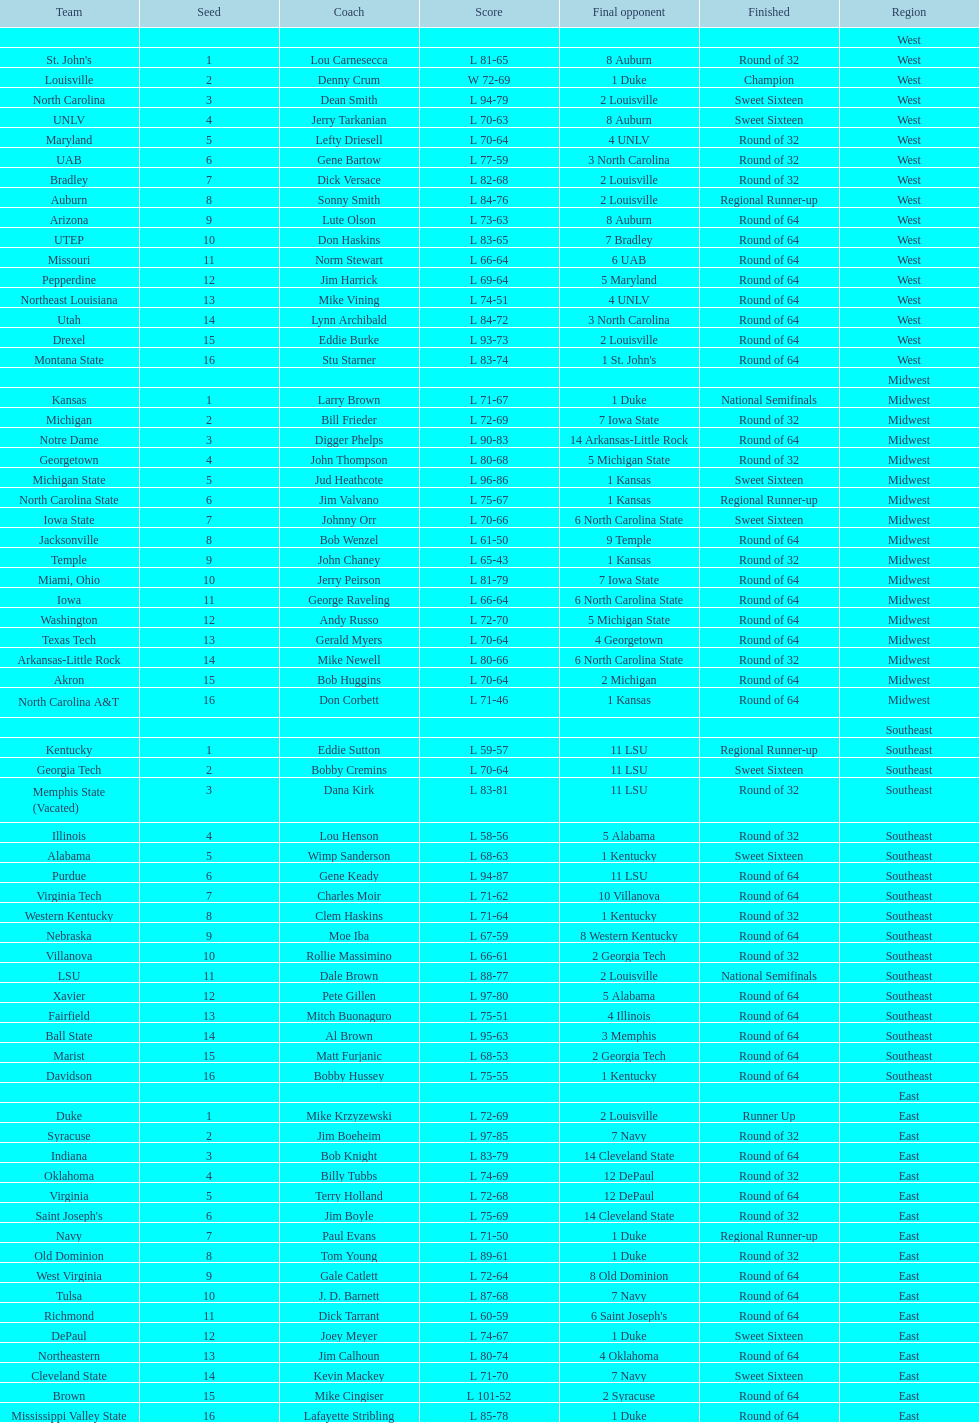What team finished at the top of all else and was finished as champions? Louisville. I'm looking to parse the entire table for insights. Could you assist me with that? {'header': ['Team', 'Seed', 'Coach', 'Score', 'Final opponent', 'Finished', 'Region'], 'rows': [['', '', '', '', '', '', 'West'], ["St. John's", '1', 'Lou Carnesecca', 'L 81-65', '8 Auburn', 'Round of 32', 'West'], ['Louisville', '2', 'Denny Crum', 'W 72-69', '1 Duke', 'Champion', 'West'], ['North Carolina', '3', 'Dean Smith', 'L 94-79', '2 Louisville', 'Sweet Sixteen', 'West'], ['UNLV', '4', 'Jerry Tarkanian', 'L 70-63', '8 Auburn', 'Sweet Sixteen', 'West'], ['Maryland', '5', 'Lefty Driesell', 'L 70-64', '4 UNLV', 'Round of 32', 'West'], ['UAB', '6', 'Gene Bartow', 'L 77-59', '3 North Carolina', 'Round of 32', 'West'], ['Bradley', '7', 'Dick Versace', 'L 82-68', '2 Louisville', 'Round of 32', 'West'], ['Auburn', '8', 'Sonny Smith', 'L 84-76', '2 Louisville', 'Regional Runner-up', 'West'], ['Arizona', '9', 'Lute Olson', 'L 73-63', '8 Auburn', 'Round of 64', 'West'], ['UTEP', '10', 'Don Haskins', 'L 83-65', '7 Bradley', 'Round of 64', 'West'], ['Missouri', '11', 'Norm Stewart', 'L 66-64', '6 UAB', 'Round of 64', 'West'], ['Pepperdine', '12', 'Jim Harrick', 'L 69-64', '5 Maryland', 'Round of 64', 'West'], ['Northeast Louisiana', '13', 'Mike Vining', 'L 74-51', '4 UNLV', 'Round of 64', 'West'], ['Utah', '14', 'Lynn Archibald', 'L 84-72', '3 North Carolina', 'Round of 64', 'West'], ['Drexel', '15', 'Eddie Burke', 'L 93-73', '2 Louisville', 'Round of 64', 'West'], ['Montana State', '16', 'Stu Starner', 'L 83-74', "1 St. John's", 'Round of 64', 'West'], ['', '', '', '', '', '', 'Midwest'], ['Kansas', '1', 'Larry Brown', 'L 71-67', '1 Duke', 'National Semifinals', 'Midwest'], ['Michigan', '2', 'Bill Frieder', 'L 72-69', '7 Iowa State', 'Round of 32', 'Midwest'], ['Notre Dame', '3', 'Digger Phelps', 'L 90-83', '14 Arkansas-Little Rock', 'Round of 64', 'Midwest'], ['Georgetown', '4', 'John Thompson', 'L 80-68', '5 Michigan State', 'Round of 32', 'Midwest'], ['Michigan State', '5', 'Jud Heathcote', 'L 96-86', '1 Kansas', 'Sweet Sixteen', 'Midwest'], ['North Carolina State', '6', 'Jim Valvano', 'L 75-67', '1 Kansas', 'Regional Runner-up', 'Midwest'], ['Iowa State', '7', 'Johnny Orr', 'L 70-66', '6 North Carolina State', 'Sweet Sixteen', 'Midwest'], ['Jacksonville', '8', 'Bob Wenzel', 'L 61-50', '9 Temple', 'Round of 64', 'Midwest'], ['Temple', '9', 'John Chaney', 'L 65-43', '1 Kansas', 'Round of 32', 'Midwest'], ['Miami, Ohio', '10', 'Jerry Peirson', 'L 81-79', '7 Iowa State', 'Round of 64', 'Midwest'], ['Iowa', '11', 'George Raveling', 'L 66-64', '6 North Carolina State', 'Round of 64', 'Midwest'], ['Washington', '12', 'Andy Russo', 'L 72-70', '5 Michigan State', 'Round of 64', 'Midwest'], ['Texas Tech', '13', 'Gerald Myers', 'L 70-64', '4 Georgetown', 'Round of 64', 'Midwest'], ['Arkansas-Little Rock', '14', 'Mike Newell', 'L 80-66', '6 North Carolina State', 'Round of 32', 'Midwest'], ['Akron', '15', 'Bob Huggins', 'L 70-64', '2 Michigan', 'Round of 64', 'Midwest'], ['North Carolina A&T', '16', 'Don Corbett', 'L 71-46', '1 Kansas', 'Round of 64', 'Midwest'], ['', '', '', '', '', '', 'Southeast'], ['Kentucky', '1', 'Eddie Sutton', 'L 59-57', '11 LSU', 'Regional Runner-up', 'Southeast'], ['Georgia Tech', '2', 'Bobby Cremins', 'L 70-64', '11 LSU', 'Sweet Sixteen', 'Southeast'], ['Memphis State (Vacated)', '3', 'Dana Kirk', 'L 83-81', '11 LSU', 'Round of 32', 'Southeast'], ['Illinois', '4', 'Lou Henson', 'L 58-56', '5 Alabama', 'Round of 32', 'Southeast'], ['Alabama', '5', 'Wimp Sanderson', 'L 68-63', '1 Kentucky', 'Sweet Sixteen', 'Southeast'], ['Purdue', '6', 'Gene Keady', 'L 94-87', '11 LSU', 'Round of 64', 'Southeast'], ['Virginia Tech', '7', 'Charles Moir', 'L 71-62', '10 Villanova', 'Round of 64', 'Southeast'], ['Western Kentucky', '8', 'Clem Haskins', 'L 71-64', '1 Kentucky', 'Round of 32', 'Southeast'], ['Nebraska', '9', 'Moe Iba', 'L 67-59', '8 Western Kentucky', 'Round of 64', 'Southeast'], ['Villanova', '10', 'Rollie Massimino', 'L 66-61', '2 Georgia Tech', 'Round of 32', 'Southeast'], ['LSU', '11', 'Dale Brown', 'L 88-77', '2 Louisville', 'National Semifinals', 'Southeast'], ['Xavier', '12', 'Pete Gillen', 'L 97-80', '5 Alabama', 'Round of 64', 'Southeast'], ['Fairfield', '13', 'Mitch Buonaguro', 'L 75-51', '4 Illinois', 'Round of 64', 'Southeast'], ['Ball State', '14', 'Al Brown', 'L 95-63', '3 Memphis', 'Round of 64', 'Southeast'], ['Marist', '15', 'Matt Furjanic', 'L 68-53', '2 Georgia Tech', 'Round of 64', 'Southeast'], ['Davidson', '16', 'Bobby Hussey', 'L 75-55', '1 Kentucky', 'Round of 64', 'Southeast'], ['', '', '', '', '', '', 'East'], ['Duke', '1', 'Mike Krzyzewski', 'L 72-69', '2 Louisville', 'Runner Up', 'East'], ['Syracuse', '2', 'Jim Boeheim', 'L 97-85', '7 Navy', 'Round of 32', 'East'], ['Indiana', '3', 'Bob Knight', 'L 83-79', '14 Cleveland State', 'Round of 64', 'East'], ['Oklahoma', '4', 'Billy Tubbs', 'L 74-69', '12 DePaul', 'Round of 32', 'East'], ['Virginia', '5', 'Terry Holland', 'L 72-68', '12 DePaul', 'Round of 64', 'East'], ["Saint Joseph's", '6', 'Jim Boyle', 'L 75-69', '14 Cleveland State', 'Round of 32', 'East'], ['Navy', '7', 'Paul Evans', 'L 71-50', '1 Duke', 'Regional Runner-up', 'East'], ['Old Dominion', '8', 'Tom Young', 'L 89-61', '1 Duke', 'Round of 32', 'East'], ['West Virginia', '9', 'Gale Catlett', 'L 72-64', '8 Old Dominion', 'Round of 64', 'East'], ['Tulsa', '10', 'J. D. Barnett', 'L 87-68', '7 Navy', 'Round of 64', 'East'], ['Richmond', '11', 'Dick Tarrant', 'L 60-59', "6 Saint Joseph's", 'Round of 64', 'East'], ['DePaul', '12', 'Joey Meyer', 'L 74-67', '1 Duke', 'Sweet Sixteen', 'East'], ['Northeastern', '13', 'Jim Calhoun', 'L 80-74', '4 Oklahoma', 'Round of 64', 'East'], ['Cleveland State', '14', 'Kevin Mackey', 'L 71-70', '7 Navy', 'Sweet Sixteen', 'East'], ['Brown', '15', 'Mike Cingiser', 'L 101-52', '2 Syracuse', 'Round of 64', 'East'], ['Mississippi Valley State', '16', 'Lafayette Stribling', 'L 85-78', '1 Duke', 'Round of 64', 'East']]} 